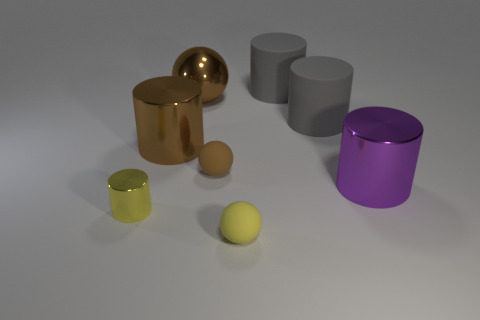Subtract all brown balls. How many gray cylinders are left? 2 Subtract 1 spheres. How many spheres are left? 2 Add 1 gray things. How many objects exist? 9 Subtract all yellow shiny cylinders. How many cylinders are left? 4 Subtract all purple cylinders. How many cylinders are left? 4 Subtract all red cylinders. Subtract all brown spheres. How many cylinders are left? 5 Add 7 big metallic spheres. How many big metallic spheres are left? 8 Add 5 big shiny objects. How many big shiny objects exist? 8 Subtract 0 red cubes. How many objects are left? 8 Subtract all spheres. How many objects are left? 5 